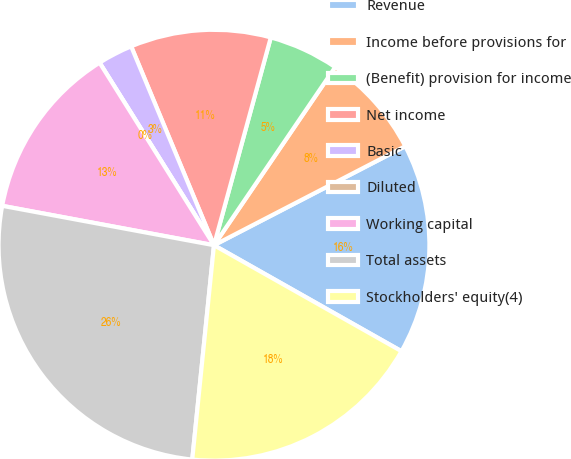<chart> <loc_0><loc_0><loc_500><loc_500><pie_chart><fcel>Revenue<fcel>Income before provisions for<fcel>(Benefit) provision for income<fcel>Net income<fcel>Basic<fcel>Diluted<fcel>Working capital<fcel>Total assets<fcel>Stockholders' equity(4)<nl><fcel>15.79%<fcel>7.89%<fcel>5.26%<fcel>10.53%<fcel>2.63%<fcel>0.0%<fcel>13.16%<fcel>26.32%<fcel>18.42%<nl></chart> 